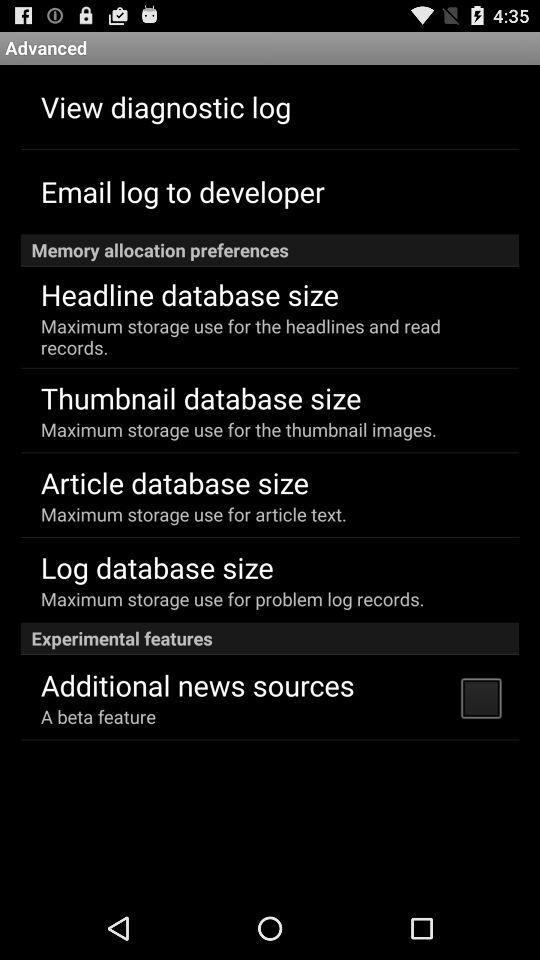How many more memory allocation preferences are there than experimental features?
Answer the question using a single word or phrase. 3 